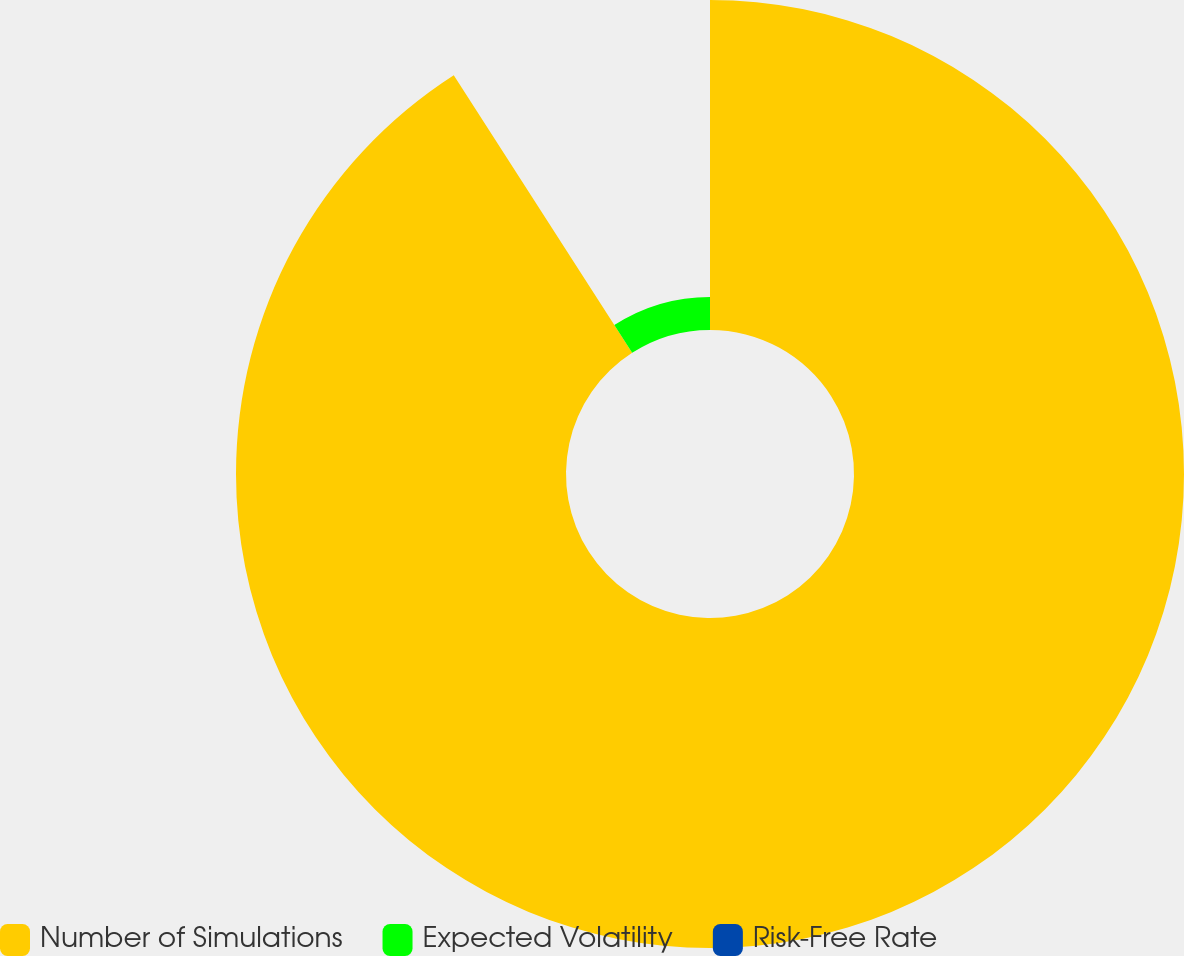Convert chart to OTSL. <chart><loc_0><loc_0><loc_500><loc_500><pie_chart><fcel>Number of Simulations<fcel>Expected Volatility<fcel>Risk-Free Rate<nl><fcel>90.91%<fcel>9.09%<fcel>0.0%<nl></chart> 